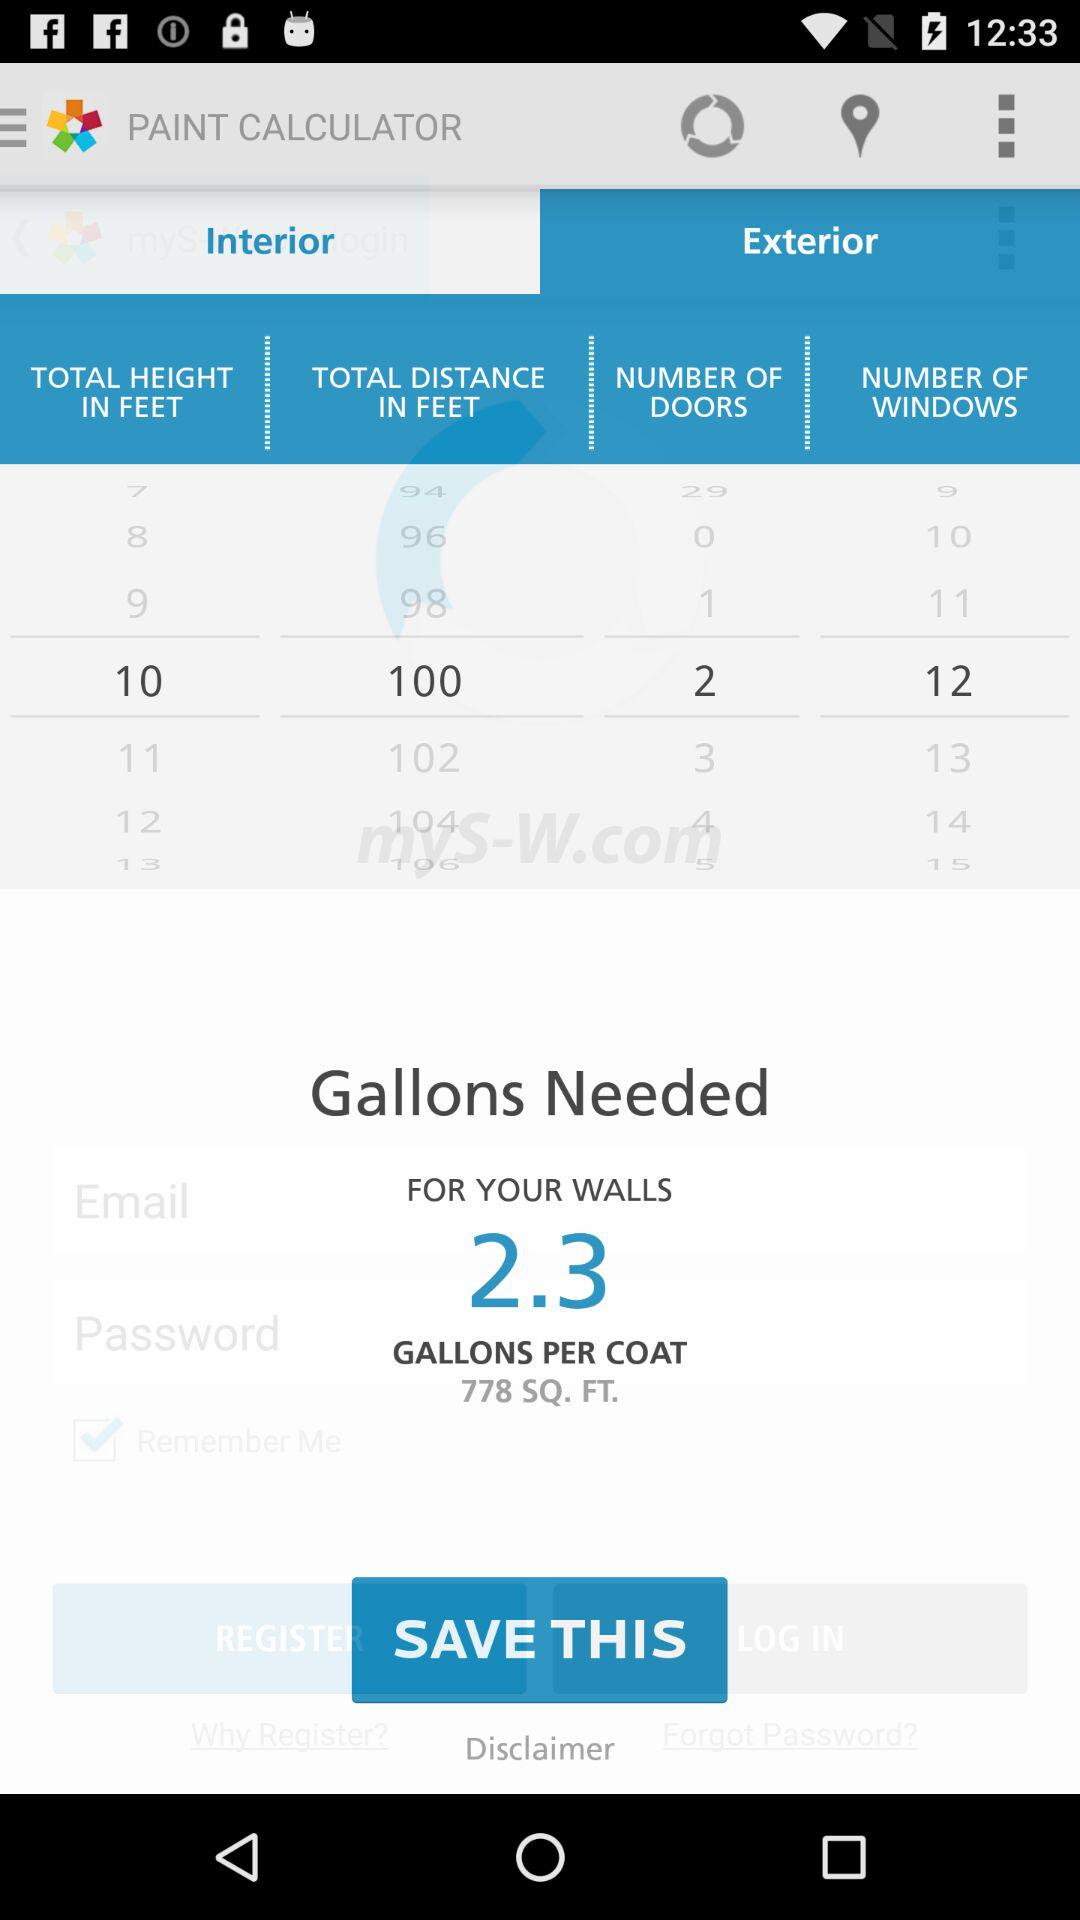How many gallons of paint does the user need for 2 coats?
Answer the question using a single word or phrase. 4.6 